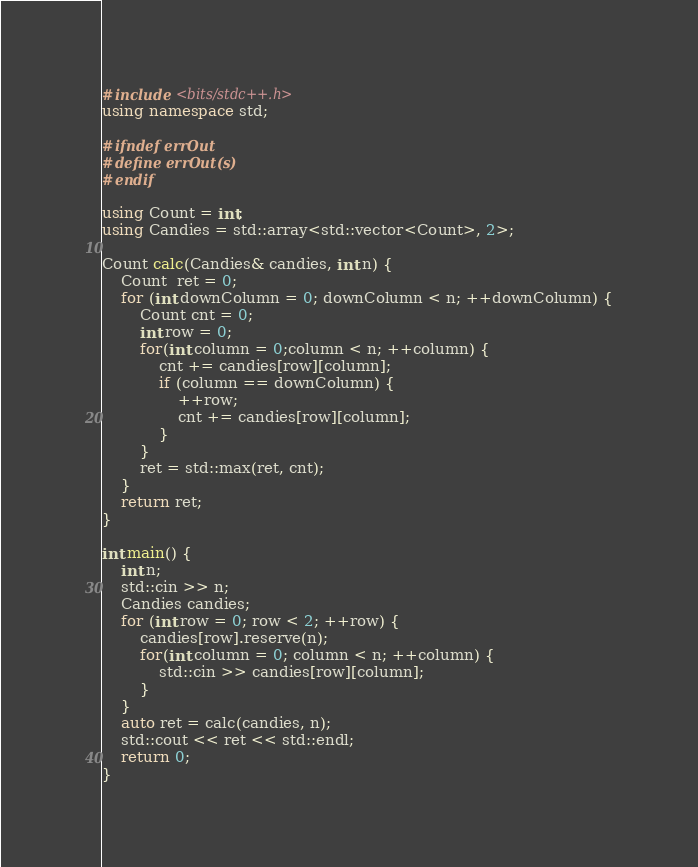Convert code to text. <code><loc_0><loc_0><loc_500><loc_500><_C++_>#include <bits/stdc++.h>
using namespace std;

#ifndef errOut
#define errOut(s)
#endif

using Count = int;
using Candies = std::array<std::vector<Count>, 2>;

Count calc(Candies& candies, int n) {
    Count  ret = 0;
    for (int downColumn = 0; downColumn < n; ++downColumn) {
        Count cnt = 0;
        int row = 0;
        for(int column = 0;column < n; ++column) {
            cnt += candies[row][column];
            if (column == downColumn) {
                ++row;
                cnt += candies[row][column];
            }
        }
        ret = std::max(ret, cnt);
    }
    return ret;
}

int main() {
    int n;
    std::cin >> n;
    Candies candies;
    for (int row = 0; row < 2; ++row) {
        candies[row].reserve(n);
        for(int column = 0; column < n; ++column) {
            std::cin >> candies[row][column];
        }
    }
    auto ret = calc(candies, n);
    std::cout << ret << std::endl;
    return 0;
}
</code> 